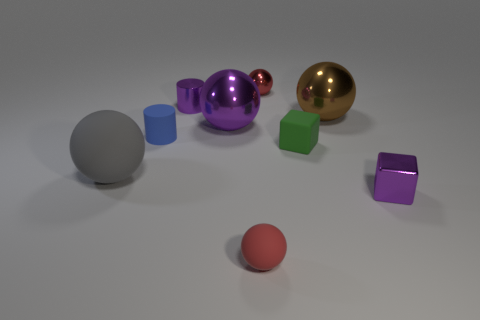Subtract 2 balls. How many balls are left? 3 Subtract all gray balls. How many balls are left? 4 Subtract all tiny metallic balls. How many balls are left? 4 Subtract all cyan spheres. Subtract all gray blocks. How many spheres are left? 5 Add 1 purple metal cubes. How many objects exist? 10 Subtract all spheres. How many objects are left? 4 Subtract 0 blue balls. How many objects are left? 9 Subtract all small balls. Subtract all purple things. How many objects are left? 4 Add 9 purple metallic cylinders. How many purple metallic cylinders are left? 10 Add 4 purple shiny balls. How many purple shiny balls exist? 5 